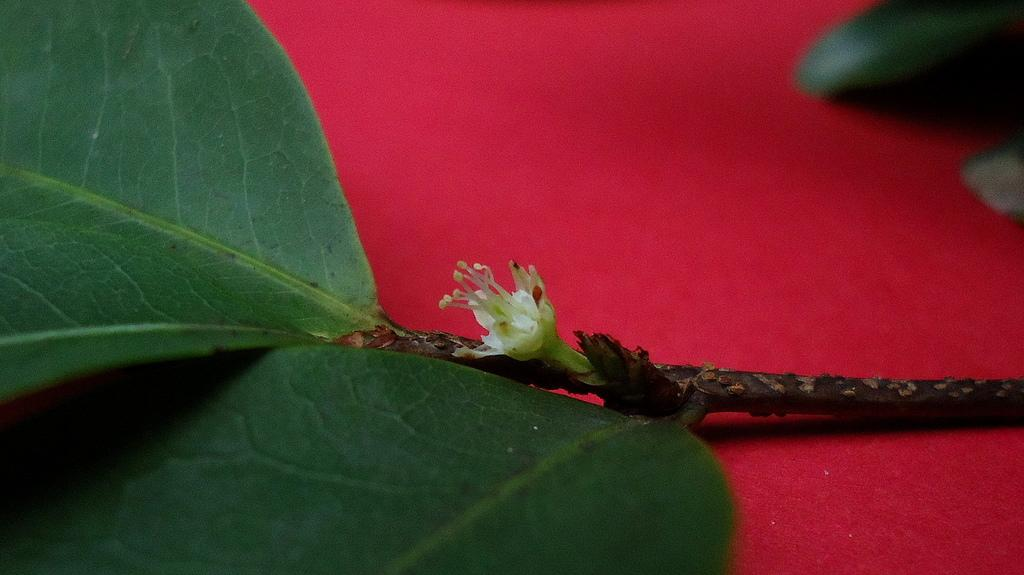What is attached to the stem in the image? The stem has a flower and leaves. What color is the surface on which the stem is placed? The stem is placed on a red surface. Can you describe the additional leaf in the image? There is a leaf in the top right corner of the image. What direction is the sun shining from in the image? There is no sun present in the image, so it cannot be determined from which direction the sun is shining. 